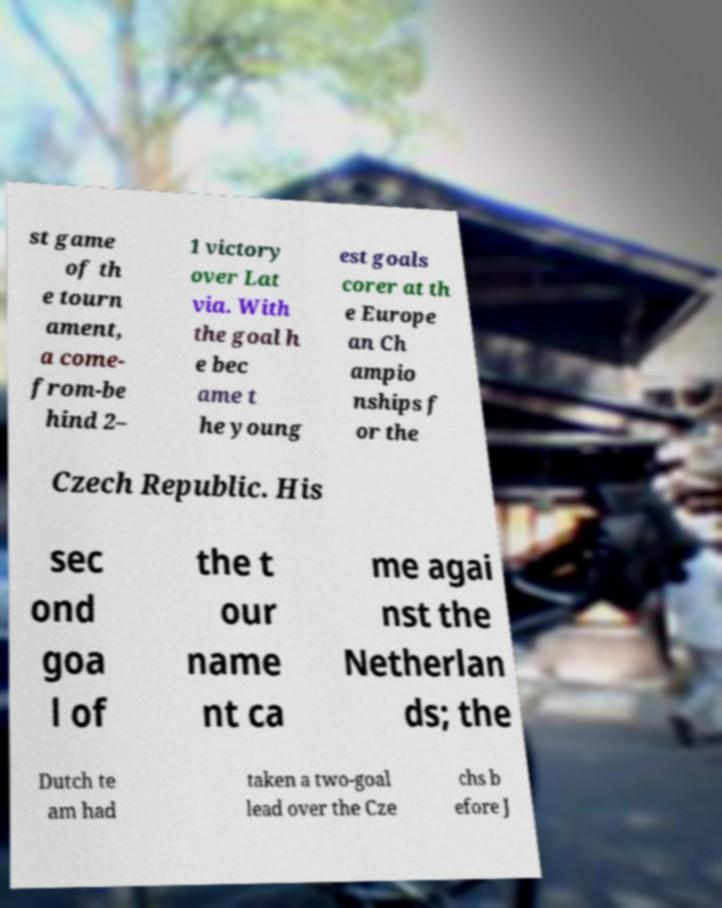Can you accurately transcribe the text from the provided image for me? st game of th e tourn ament, a come- from-be hind 2– 1 victory over Lat via. With the goal h e bec ame t he young est goals corer at th e Europe an Ch ampio nships f or the Czech Republic. His sec ond goa l of the t our name nt ca me agai nst the Netherlan ds; the Dutch te am had taken a two-goal lead over the Cze chs b efore J 